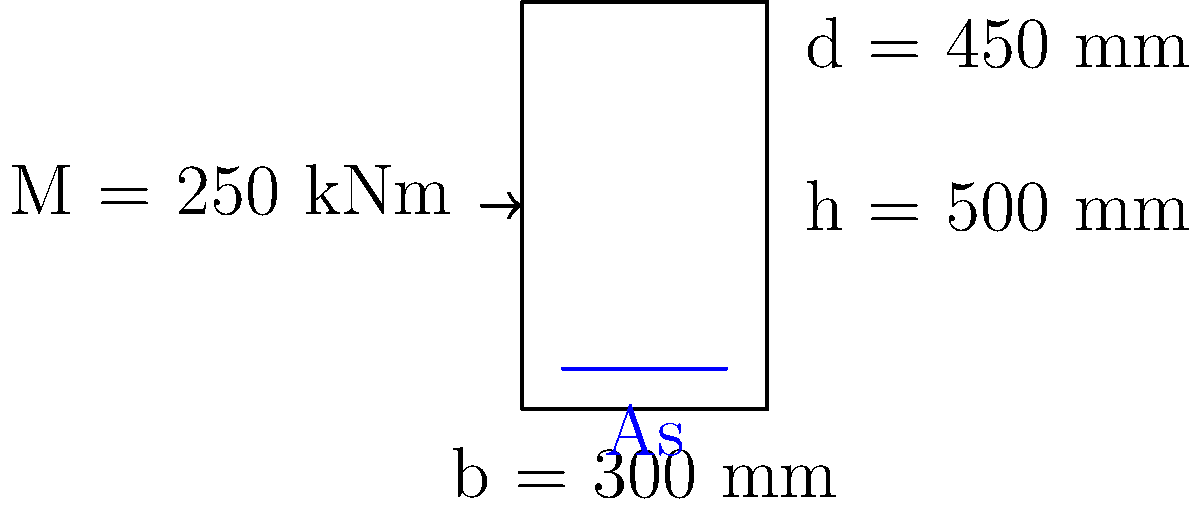As an experienced goalkeeper, you understand the importance of proper positioning and structure. Similarly, in civil engineering, the correct positioning and amount of reinforcement in a concrete beam is crucial. Given a rectangular concrete beam with width b = 300 mm, total depth h = 500 mm, and effective depth d = 450 mm, subjected to an ultimate moment M = 250 kNm, calculate the required area of tension reinforcement (As). Assume the following material properties: concrete strength $f_{ck} = 30$ MPa, steel yield strength $f_y = 500$ MPa, and the maximum allowable steel ratio $\rho_{max} = 0.04$. Let's approach this step-by-step, just like how you'd break down a complex save into manageable steps:

1) First, calculate the lever arm z:
   Assume z = 0.9d = 0.9 × 450 = 405 mm

2) Calculate the required area of steel (As) using the moment equation:
   $M = 0.87 f_y A_s z$
   $250 \times 10^6 = 0.87 \times 500 \times A_s \times 405$
   $A_s = \frac{250 \times 10^6}{0.87 \times 500 \times 405} = 1423$ mm²

3) Check if this is within the maximum allowable reinforcement:
   $A_{s,max} = \rho_{max} \times b \times d = 0.04 \times 300 \times 450 = 5400$ mm²
   1423 mm² < 5400 mm², so it's within the limit.

4) Verify the assumption of z:
   $x = \frac{A_s f_y}{0.567 f_{ck} b} = \frac{1423 \times 500}{0.567 \times 30 \times 300} = 139$ mm
   $z = d - 0.4x = 450 - 0.4 \times 139 = 394$ mm

5) This is close to our initial assumption (405 mm), but for more accuracy, we can recalculate As:
   $A_s = \frac{250 \times 10^6}{0.87 \times 500 \times 394} = 1463$ mm²

Therefore, the required area of tension reinforcement is 1463 mm².
Answer: $A_s = 1463$ mm² 